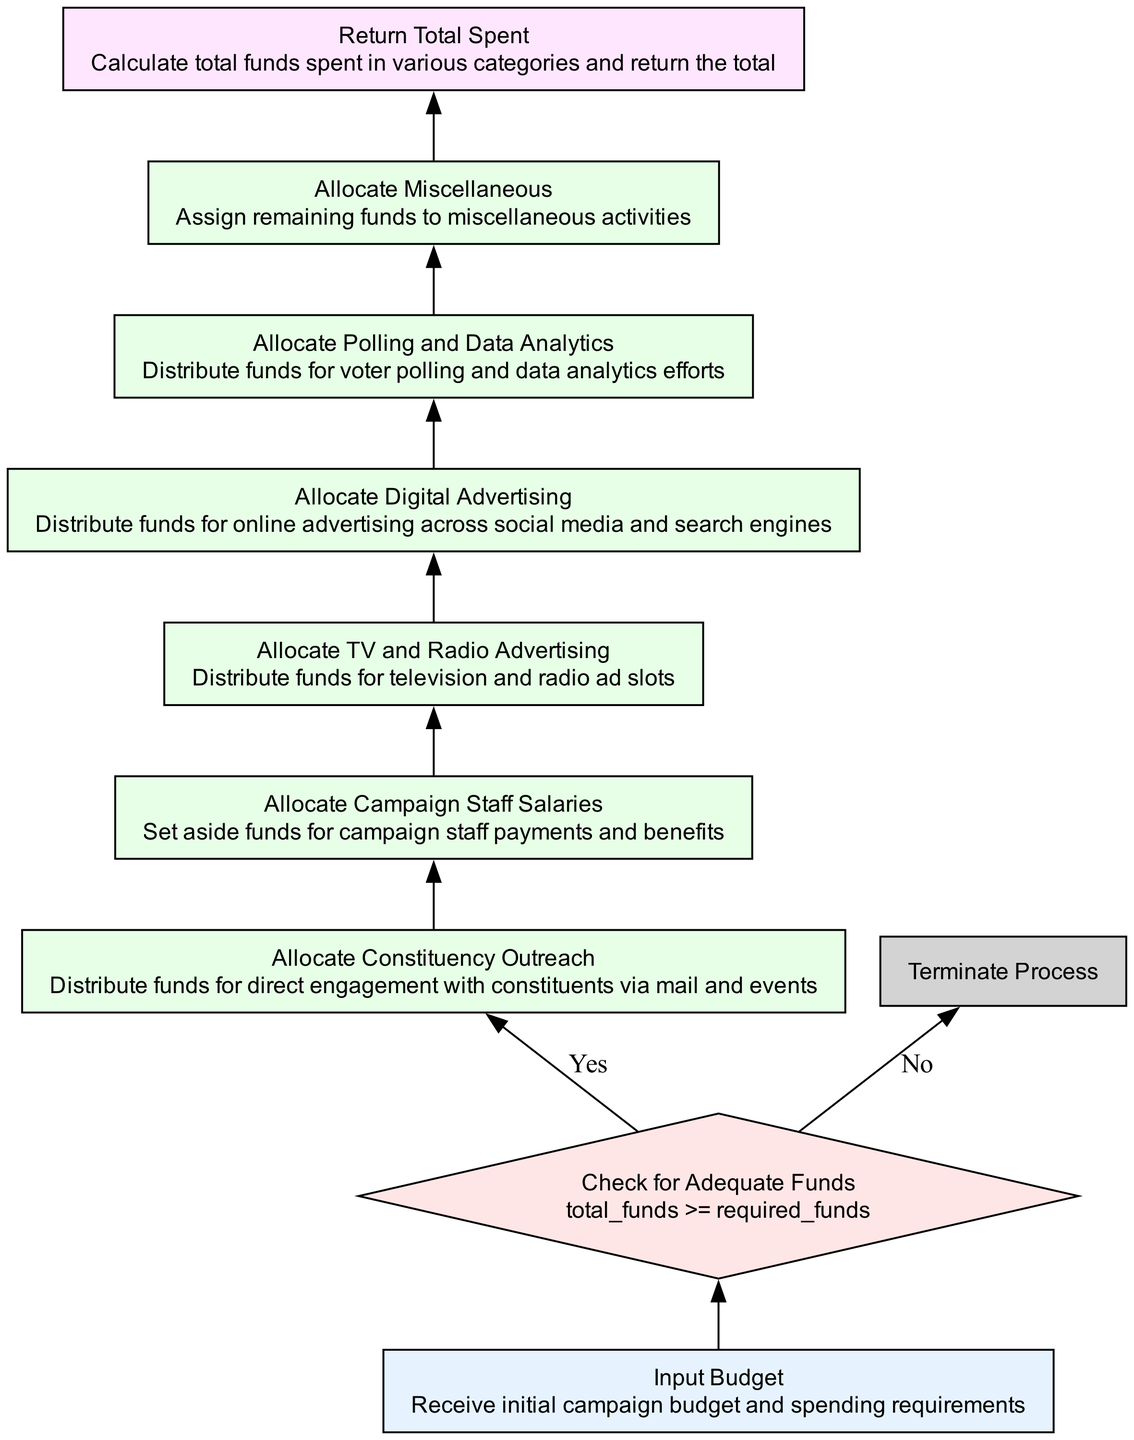What is the first step in the diagram? The first step in the diagram is "Input Budget," which is where the initial campaign budget and spending requirements are received.
Answer: Input Budget How many process nodes are there? There are five process nodes in the diagram: "Allocate Constituency Outreach," "Allocate Campaign Staff Salaries," "Allocate TV and Radio Advertising," "Allocate Digital Advertising," and "Allocate Polling and Data Analytics."
Answer: Five What happens if funds are inadequate? If the funds are inadequate ("No" branch), the process will terminate immediately and not proceed to any allocation steps.
Answer: Terminate Process What node follows "Allocate Polling and Data Analytics"? The node that follows "Allocate Polling and Data Analytics" is "Allocate Miscellaneous," indicating that funds are assigned to miscellaneous activities.
Answer: Allocate Miscellaneous What is the condition checked before fund allocation? The condition checked before fund allocation is whether the total funds are greater than or equal to required funds ("total_funds >= required_funds").
Answer: total_funds >= required_funds What does the return statement at the end signify? The return statement "Return Total Spent" signifies that the total funds spent across various categories are calculated and returned to the caller after all allocations are made.
Answer: Return Total Spent Which node represents a decision point? The node that represents a decision point is "Check for Adequate Funds," where the flow diverges based on the availability of sufficient funds.
Answer: Check for Adequate Funds What is the last action performed in the process? The last action performed in the process is "Return Total Spent," which indicates the conclusion of fund allocation and reporting of total expenses.
Answer: Return Total Spent 